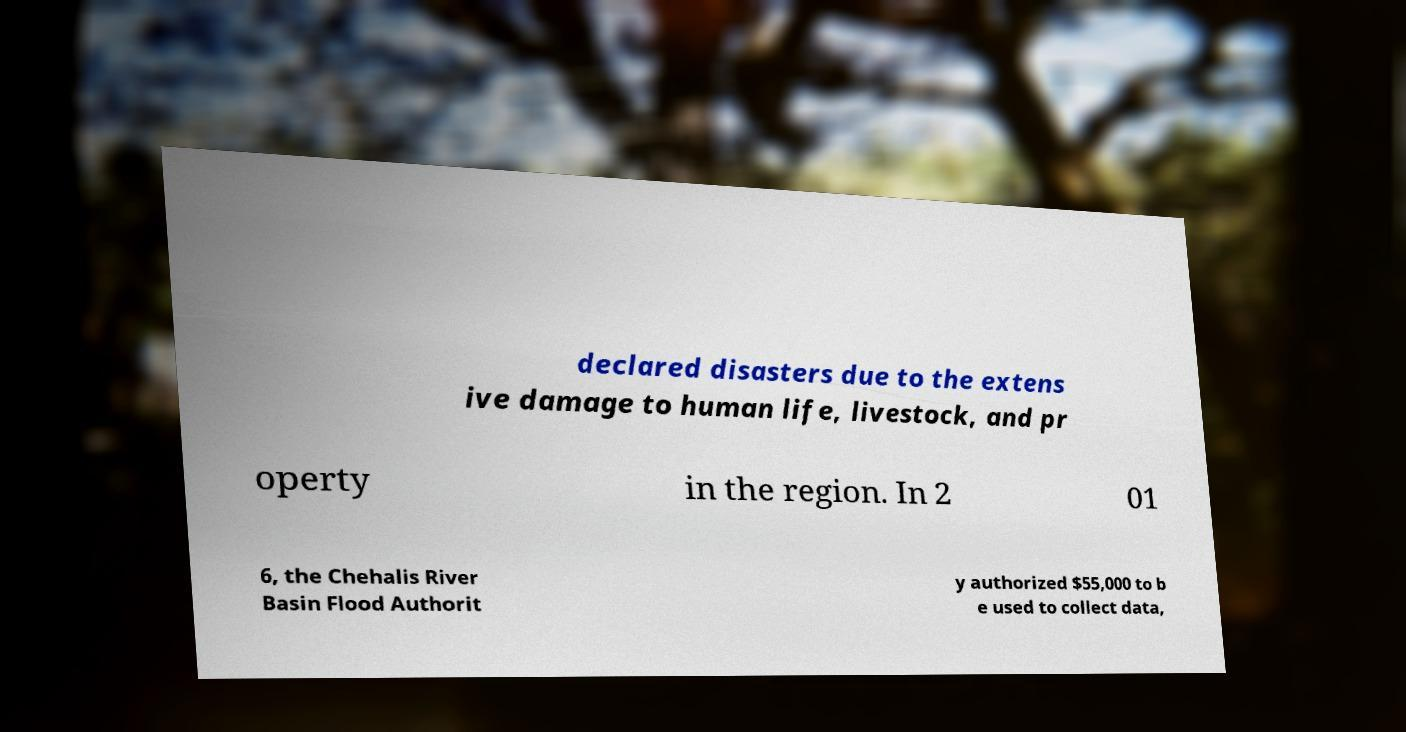Could you extract and type out the text from this image? declared disasters due to the extens ive damage to human life, livestock, and pr operty in the region. In 2 01 6, the Chehalis River Basin Flood Authorit y authorized $55,000 to b e used to collect data, 